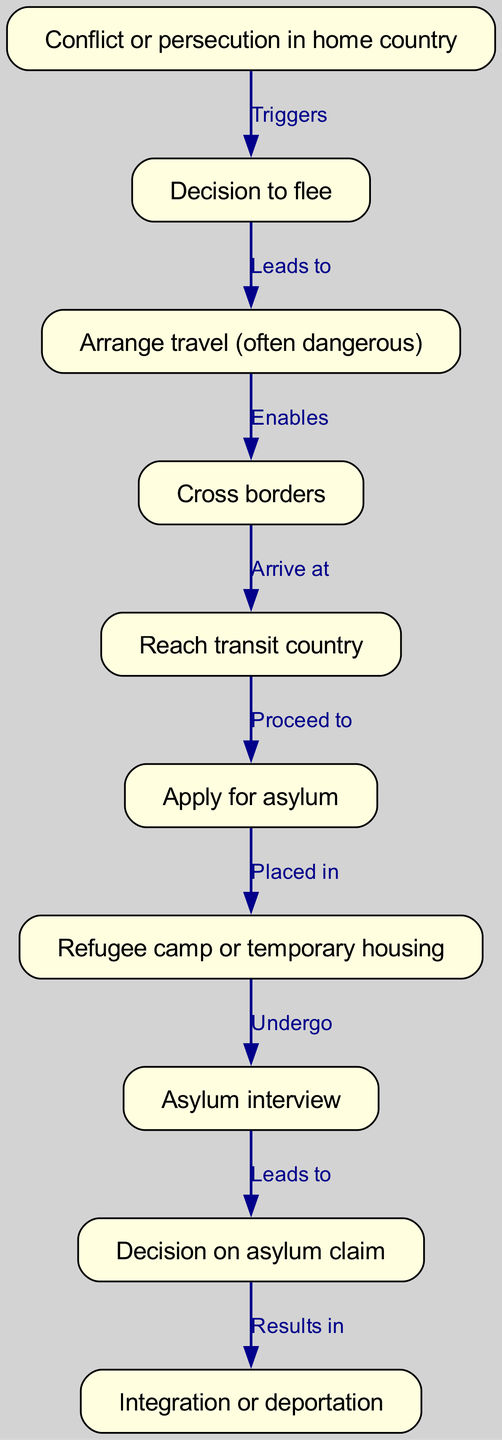What is the first step in the journey of an asylum seeker? The diagram indicates that the journey begins with the "Conflict or persecution in home country," which is the first node in the flow.
Answer: Conflict or persecution in home country How many nodes are in the diagram? By counting the nodes listed, there are a total of 10 distinct nodes in the flow chart.
Answer: 10 What triggers the decision to flee? The diagram shows that "Conflict or persecution in home country" triggers the "Decision to flee," indicating the main reason for this decision.
Answer: Conflict or persecution in home country What happens after applying for asylum? According to the flow chart, after the "Apply for asylum" node, the next step is being "Placed in a refugee camp or temporary housing."
Answer: Placed in refugee camp or temporary housing What is the final outcome of the asylum claim process? The last node states that the process results in either "Integration or deportation," indicating the two possible outcomes of the asylum claim.
Answer: Integration or deportation How does one arrive at the transit country? The flow diagram indicates that crossing borders, depicted in the node "Cross borders," enables the arrival at the transit country.
Answer: Cross borders Which steps are involved before the asylum interview? To reach the "Asylum interview," one must first apply for asylum and be placed in a refugee camp or temporary housing, linking these two nodes in sequence.
Answer: Apply for asylum, Placed in refugee camp or temporary housing What leads to the decision on the asylum claim? The diagram shows that undergoing "Asylum interview" leads to the "Decision on asylum claim," thus indicating that the interview is pivotal in making this decision.
Answer: Asylum interview Which node involves dangerous actions? The node "Arrange travel (often dangerous)" indicates the specific step in the diagram where dangerous actions take place during the asylum seeker's journey.
Answer: Arrange travel (often dangerous) 